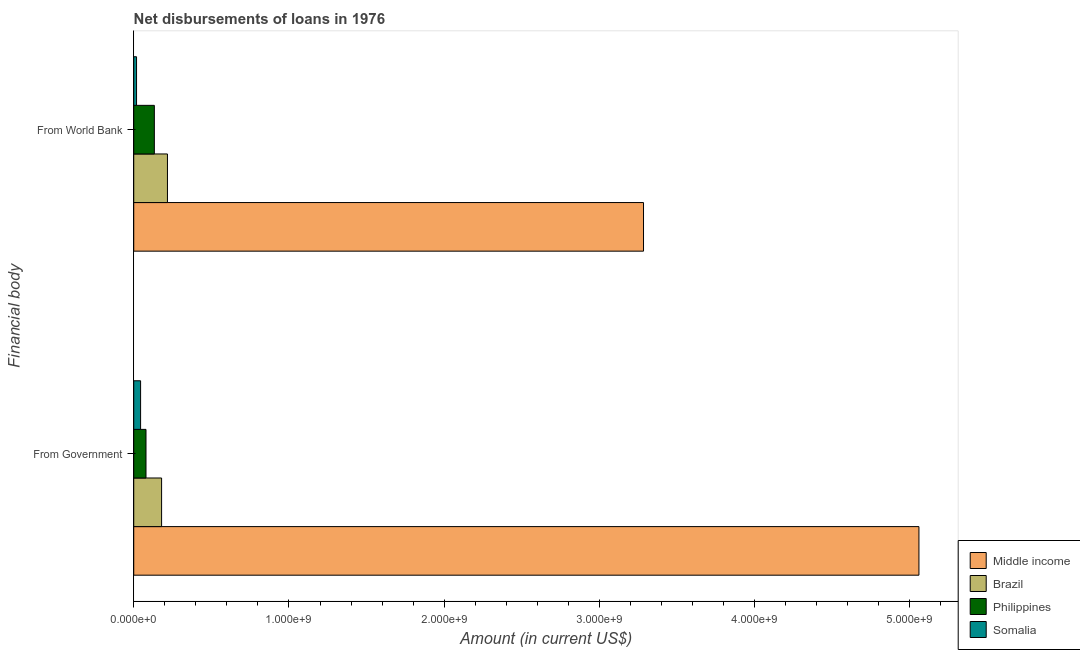How many bars are there on the 1st tick from the top?
Offer a very short reply. 4. How many bars are there on the 1st tick from the bottom?
Provide a short and direct response. 4. What is the label of the 1st group of bars from the top?
Make the answer very short. From World Bank. What is the net disbursements of loan from world bank in Brazil?
Provide a short and direct response. 2.17e+08. Across all countries, what is the maximum net disbursements of loan from world bank?
Keep it short and to the point. 3.28e+09. Across all countries, what is the minimum net disbursements of loan from world bank?
Your answer should be compact. 1.81e+07. In which country was the net disbursements of loan from world bank minimum?
Provide a short and direct response. Somalia. What is the total net disbursements of loan from world bank in the graph?
Your answer should be very brief. 3.65e+09. What is the difference between the net disbursements of loan from government in Somalia and that in Middle income?
Offer a terse response. -5.01e+09. What is the difference between the net disbursements of loan from world bank in Brazil and the net disbursements of loan from government in Somalia?
Offer a very short reply. 1.73e+08. What is the average net disbursements of loan from world bank per country?
Make the answer very short. 9.13e+08. What is the difference between the net disbursements of loan from world bank and net disbursements of loan from government in Brazil?
Offer a very short reply. 3.78e+07. What is the ratio of the net disbursements of loan from government in Middle income to that in Brazil?
Your answer should be compact. 28.19. What does the 4th bar from the bottom in From Government represents?
Keep it short and to the point. Somalia. Are all the bars in the graph horizontal?
Offer a terse response. Yes. How many countries are there in the graph?
Your answer should be very brief. 4. Are the values on the major ticks of X-axis written in scientific E-notation?
Offer a terse response. Yes. Does the graph contain grids?
Your answer should be compact. No. How are the legend labels stacked?
Keep it short and to the point. Vertical. What is the title of the graph?
Keep it short and to the point. Net disbursements of loans in 1976. Does "Estonia" appear as one of the legend labels in the graph?
Your answer should be very brief. No. What is the label or title of the X-axis?
Give a very brief answer. Amount (in current US$). What is the label or title of the Y-axis?
Your answer should be very brief. Financial body. What is the Amount (in current US$) of Middle income in From Government?
Ensure brevity in your answer.  5.06e+09. What is the Amount (in current US$) in Brazil in From Government?
Offer a very short reply. 1.79e+08. What is the Amount (in current US$) of Philippines in From Government?
Provide a succinct answer. 7.90e+07. What is the Amount (in current US$) of Somalia in From Government?
Give a very brief answer. 4.42e+07. What is the Amount (in current US$) of Middle income in From World Bank?
Your answer should be compact. 3.28e+09. What is the Amount (in current US$) in Brazil in From World Bank?
Give a very brief answer. 2.17e+08. What is the Amount (in current US$) in Philippines in From World Bank?
Your response must be concise. 1.33e+08. What is the Amount (in current US$) of Somalia in From World Bank?
Keep it short and to the point. 1.81e+07. Across all Financial body, what is the maximum Amount (in current US$) of Middle income?
Offer a terse response. 5.06e+09. Across all Financial body, what is the maximum Amount (in current US$) in Brazil?
Keep it short and to the point. 2.17e+08. Across all Financial body, what is the maximum Amount (in current US$) of Philippines?
Offer a terse response. 1.33e+08. Across all Financial body, what is the maximum Amount (in current US$) of Somalia?
Your answer should be compact. 4.42e+07. Across all Financial body, what is the minimum Amount (in current US$) in Middle income?
Offer a very short reply. 3.28e+09. Across all Financial body, what is the minimum Amount (in current US$) in Brazil?
Keep it short and to the point. 1.79e+08. Across all Financial body, what is the minimum Amount (in current US$) in Philippines?
Give a very brief answer. 7.90e+07. Across all Financial body, what is the minimum Amount (in current US$) of Somalia?
Your response must be concise. 1.81e+07. What is the total Amount (in current US$) in Middle income in the graph?
Your response must be concise. 8.34e+09. What is the total Amount (in current US$) in Brazil in the graph?
Keep it short and to the point. 3.97e+08. What is the total Amount (in current US$) of Philippines in the graph?
Provide a short and direct response. 2.12e+08. What is the total Amount (in current US$) of Somalia in the graph?
Give a very brief answer. 6.22e+07. What is the difference between the Amount (in current US$) in Middle income in From Government and that in From World Bank?
Your answer should be very brief. 1.77e+09. What is the difference between the Amount (in current US$) in Brazil in From Government and that in From World Bank?
Your response must be concise. -3.78e+07. What is the difference between the Amount (in current US$) of Philippines in From Government and that in From World Bank?
Your answer should be compact. -5.37e+07. What is the difference between the Amount (in current US$) in Somalia in From Government and that in From World Bank?
Provide a short and direct response. 2.61e+07. What is the difference between the Amount (in current US$) in Middle income in From Government and the Amount (in current US$) in Brazil in From World Bank?
Provide a short and direct response. 4.84e+09. What is the difference between the Amount (in current US$) in Middle income in From Government and the Amount (in current US$) in Philippines in From World Bank?
Your answer should be very brief. 4.93e+09. What is the difference between the Amount (in current US$) of Middle income in From Government and the Amount (in current US$) of Somalia in From World Bank?
Keep it short and to the point. 5.04e+09. What is the difference between the Amount (in current US$) in Brazil in From Government and the Amount (in current US$) in Philippines in From World Bank?
Give a very brief answer. 4.67e+07. What is the difference between the Amount (in current US$) of Brazil in From Government and the Amount (in current US$) of Somalia in From World Bank?
Provide a succinct answer. 1.61e+08. What is the difference between the Amount (in current US$) in Philippines in From Government and the Amount (in current US$) in Somalia in From World Bank?
Ensure brevity in your answer.  6.10e+07. What is the average Amount (in current US$) in Middle income per Financial body?
Provide a succinct answer. 4.17e+09. What is the average Amount (in current US$) of Brazil per Financial body?
Provide a succinct answer. 1.98e+08. What is the average Amount (in current US$) of Philippines per Financial body?
Offer a terse response. 1.06e+08. What is the average Amount (in current US$) in Somalia per Financial body?
Keep it short and to the point. 3.11e+07. What is the difference between the Amount (in current US$) of Middle income and Amount (in current US$) of Brazil in From Government?
Provide a succinct answer. 4.88e+09. What is the difference between the Amount (in current US$) of Middle income and Amount (in current US$) of Philippines in From Government?
Give a very brief answer. 4.98e+09. What is the difference between the Amount (in current US$) in Middle income and Amount (in current US$) in Somalia in From Government?
Your response must be concise. 5.01e+09. What is the difference between the Amount (in current US$) of Brazil and Amount (in current US$) of Philippines in From Government?
Your response must be concise. 1.00e+08. What is the difference between the Amount (in current US$) in Brazil and Amount (in current US$) in Somalia in From Government?
Your response must be concise. 1.35e+08. What is the difference between the Amount (in current US$) in Philippines and Amount (in current US$) in Somalia in From Government?
Make the answer very short. 3.49e+07. What is the difference between the Amount (in current US$) in Middle income and Amount (in current US$) in Brazil in From World Bank?
Your answer should be very brief. 3.07e+09. What is the difference between the Amount (in current US$) of Middle income and Amount (in current US$) of Philippines in From World Bank?
Ensure brevity in your answer.  3.15e+09. What is the difference between the Amount (in current US$) of Middle income and Amount (in current US$) of Somalia in From World Bank?
Ensure brevity in your answer.  3.27e+09. What is the difference between the Amount (in current US$) in Brazil and Amount (in current US$) in Philippines in From World Bank?
Ensure brevity in your answer.  8.45e+07. What is the difference between the Amount (in current US$) in Brazil and Amount (in current US$) in Somalia in From World Bank?
Ensure brevity in your answer.  1.99e+08. What is the difference between the Amount (in current US$) of Philippines and Amount (in current US$) of Somalia in From World Bank?
Your response must be concise. 1.15e+08. What is the ratio of the Amount (in current US$) in Middle income in From Government to that in From World Bank?
Offer a very short reply. 1.54. What is the ratio of the Amount (in current US$) of Brazil in From Government to that in From World Bank?
Make the answer very short. 0.83. What is the ratio of the Amount (in current US$) in Philippines in From Government to that in From World Bank?
Your response must be concise. 0.6. What is the ratio of the Amount (in current US$) in Somalia in From Government to that in From World Bank?
Provide a succinct answer. 2.44. What is the difference between the highest and the second highest Amount (in current US$) in Middle income?
Provide a short and direct response. 1.77e+09. What is the difference between the highest and the second highest Amount (in current US$) of Brazil?
Offer a terse response. 3.78e+07. What is the difference between the highest and the second highest Amount (in current US$) in Philippines?
Ensure brevity in your answer.  5.37e+07. What is the difference between the highest and the second highest Amount (in current US$) in Somalia?
Give a very brief answer. 2.61e+07. What is the difference between the highest and the lowest Amount (in current US$) in Middle income?
Give a very brief answer. 1.77e+09. What is the difference between the highest and the lowest Amount (in current US$) in Brazil?
Your response must be concise. 3.78e+07. What is the difference between the highest and the lowest Amount (in current US$) in Philippines?
Offer a terse response. 5.37e+07. What is the difference between the highest and the lowest Amount (in current US$) in Somalia?
Your answer should be compact. 2.61e+07. 